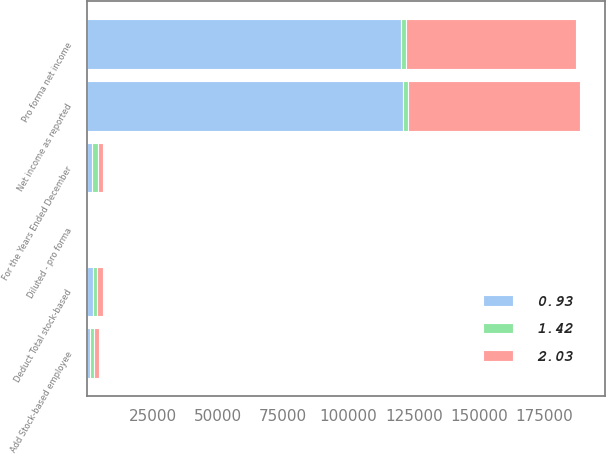Convert chart to OTSL. <chart><loc_0><loc_0><loc_500><loc_500><stacked_bar_chart><ecel><fcel>For the Years Ended December<fcel>Net income as reported<fcel>Add Stock-based employee<fcel>Deduct Total stock-based<fcel>Pro forma net income<fcel>Diluted - pro forma<nl><fcel>0.93<fcel>2004<fcel>120900<fcel>1207<fcel>2110<fcel>119997<fcel>1.42<nl><fcel>1.42<fcel>2003<fcel>2002.5<fcel>1320<fcel>1631<fcel>2002.5<fcel>2.03<nl><fcel>2.03<fcel>2002<fcel>65706<fcel>1853<fcel>2422<fcel>65137<fcel>0.93<nl></chart> 